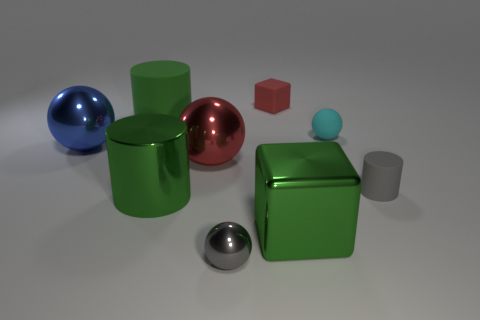Which objects in the image appear to be most similar in texture, and why? The green cube and the small gray cylinder seem to have the most similar texture as both have matte surfaces that do not reflect much light, in contrast to the other objects which have shiny surfaces with distinct reflections. 